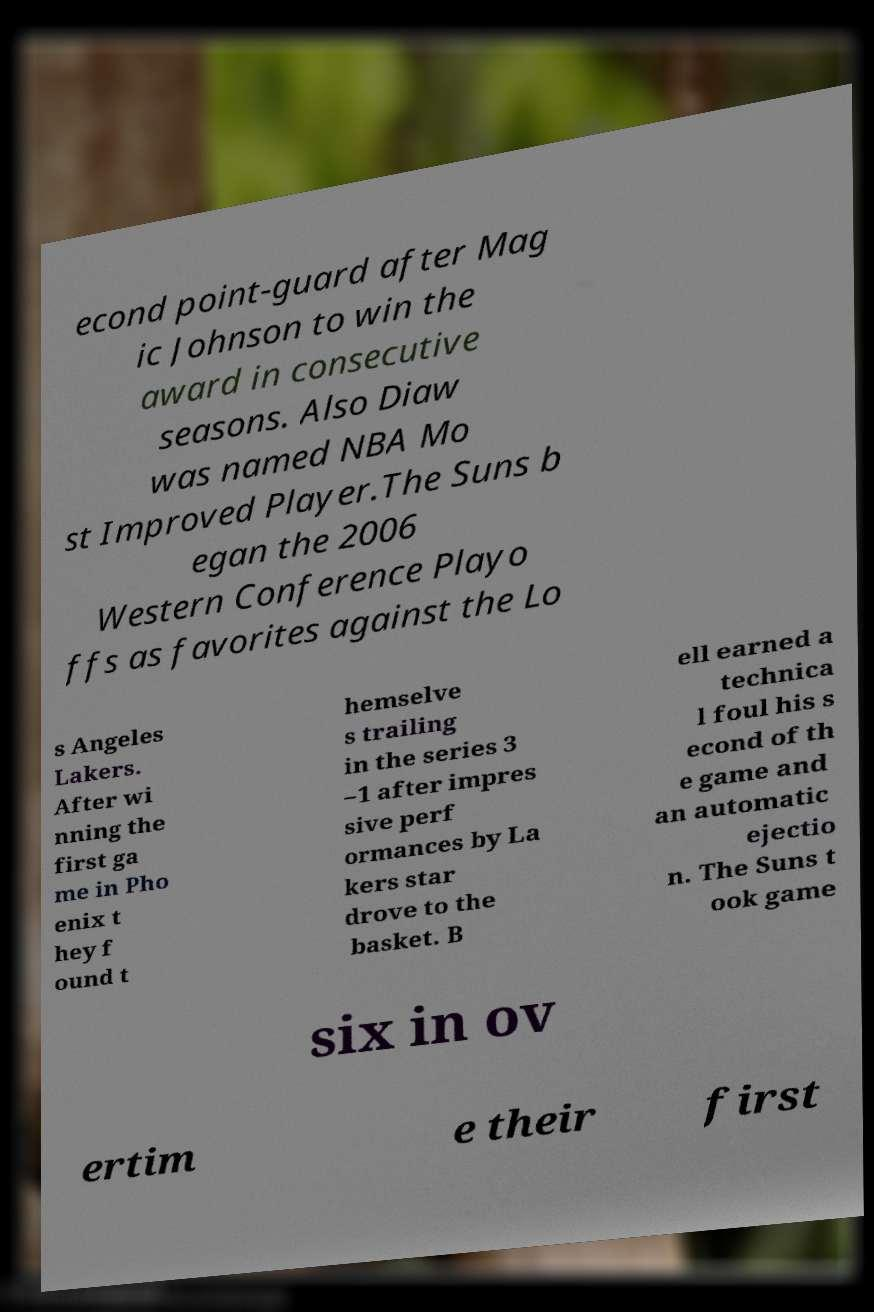Please identify and transcribe the text found in this image. econd point-guard after Mag ic Johnson to win the award in consecutive seasons. Also Diaw was named NBA Mo st Improved Player.The Suns b egan the 2006 Western Conference Playo ffs as favorites against the Lo s Angeles Lakers. After wi nning the first ga me in Pho enix t hey f ound t hemselve s trailing in the series 3 –1 after impres sive perf ormances by La kers star drove to the basket. B ell earned a technica l foul his s econd of th e game and an automatic ejectio n. The Suns t ook game six in ov ertim e their first 